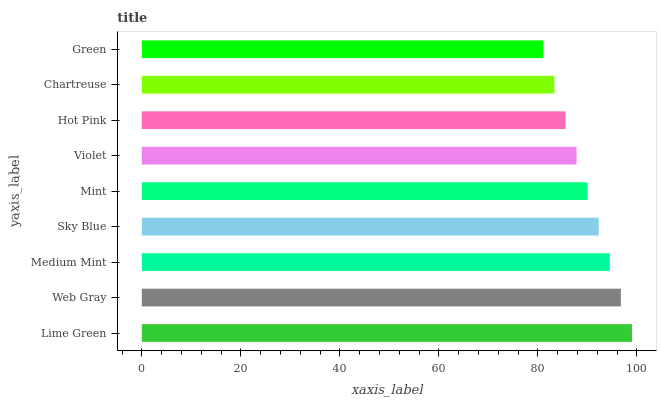Is Green the minimum?
Answer yes or no. Yes. Is Lime Green the maximum?
Answer yes or no. Yes. Is Web Gray the minimum?
Answer yes or no. No. Is Web Gray the maximum?
Answer yes or no. No. Is Lime Green greater than Web Gray?
Answer yes or no. Yes. Is Web Gray less than Lime Green?
Answer yes or no. Yes. Is Web Gray greater than Lime Green?
Answer yes or no. No. Is Lime Green less than Web Gray?
Answer yes or no. No. Is Mint the high median?
Answer yes or no. Yes. Is Mint the low median?
Answer yes or no. Yes. Is Hot Pink the high median?
Answer yes or no. No. Is Web Gray the low median?
Answer yes or no. No. 